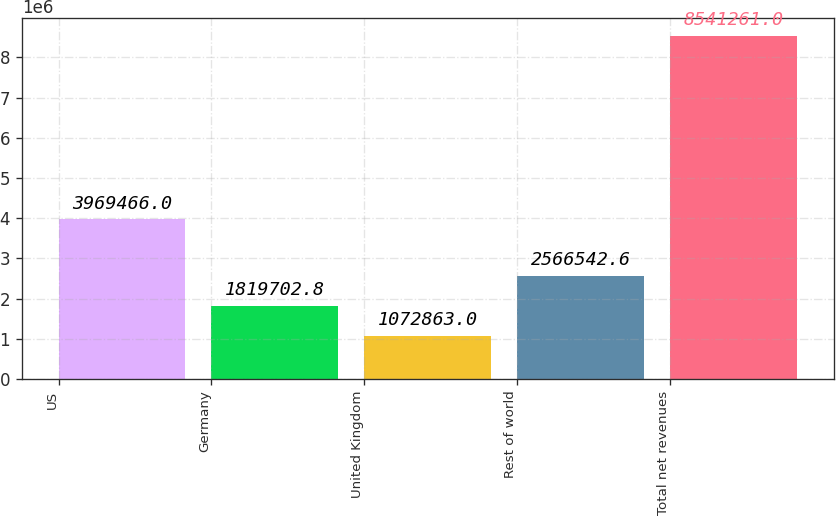<chart> <loc_0><loc_0><loc_500><loc_500><bar_chart><fcel>US<fcel>Germany<fcel>United Kingdom<fcel>Rest of world<fcel>Total net revenues<nl><fcel>3.96947e+06<fcel>1.8197e+06<fcel>1.07286e+06<fcel>2.56654e+06<fcel>8.54126e+06<nl></chart> 